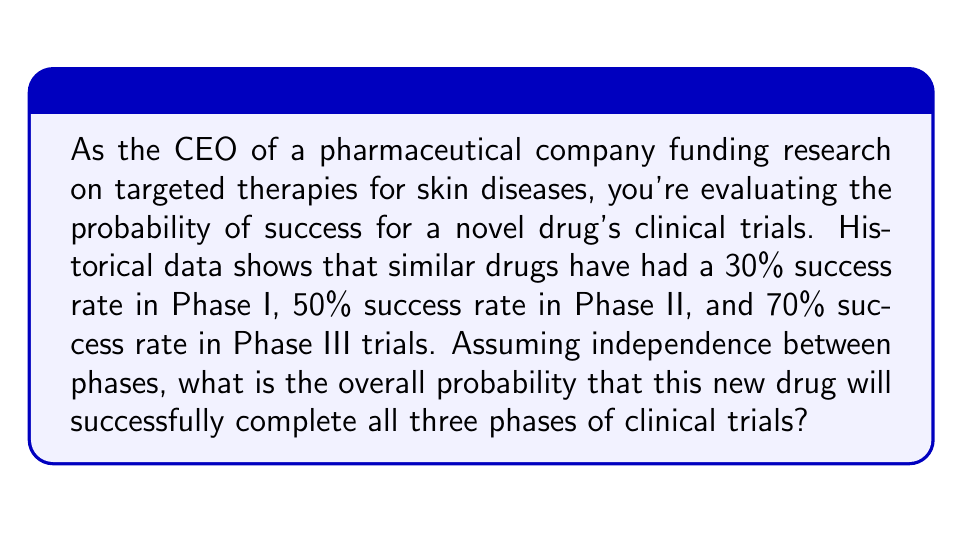Give your solution to this math problem. To solve this problem, we need to consider the probability of success for each phase of the clinical trials and then combine these probabilities to find the overall likelihood of success through all three phases.

Given:
- Phase I success rate: 30% or 0.30
- Phase II success rate: 50% or 0.50
- Phase III success rate: 70% or 0.70

Since we need the drug to successfully pass all three phases, and assuming independence between phases, we need to multiply the individual probabilities:

$$P(\text{Overall Success}) = P(\text{Phase I Success}) \times P(\text{Phase II Success}) \times P(\text{Phase III Success})$$

Substituting the given probabilities:

$$P(\text{Overall Success}) = 0.30 \times 0.50 \times 0.70$$

Calculating:

$$P(\text{Overall Success}) = 0.105$$

To express this as a percentage:

$$P(\text{Overall Success}) = 0.105 \times 100\% = 10.5\%$$

Therefore, the overall probability that the new drug will successfully complete all three phases of clinical trials is 10.5%.
Answer: 10.5% 